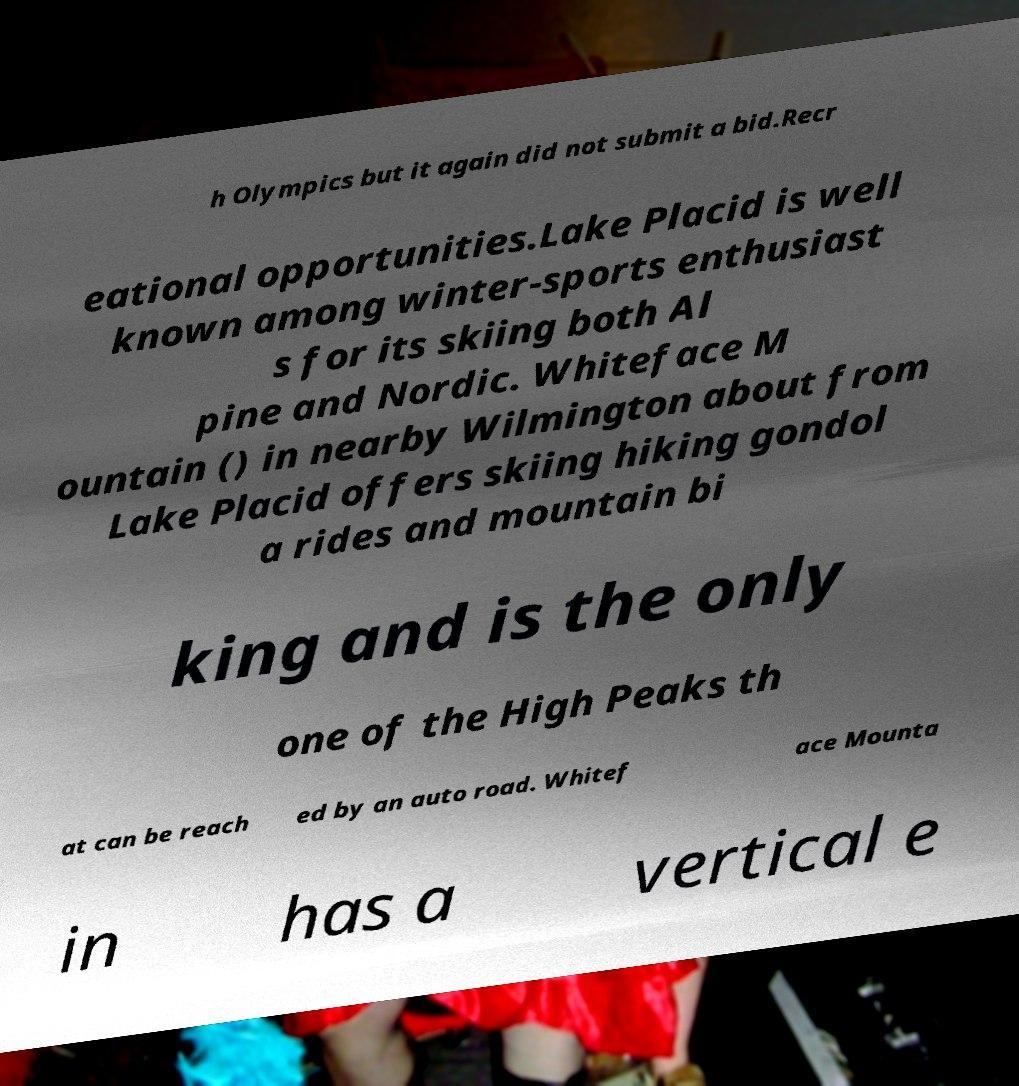Please identify and transcribe the text found in this image. h Olympics but it again did not submit a bid.Recr eational opportunities.Lake Placid is well known among winter-sports enthusiast s for its skiing both Al pine and Nordic. Whiteface M ountain () in nearby Wilmington about from Lake Placid offers skiing hiking gondol a rides and mountain bi king and is the only one of the High Peaks th at can be reach ed by an auto road. Whitef ace Mounta in has a vertical e 